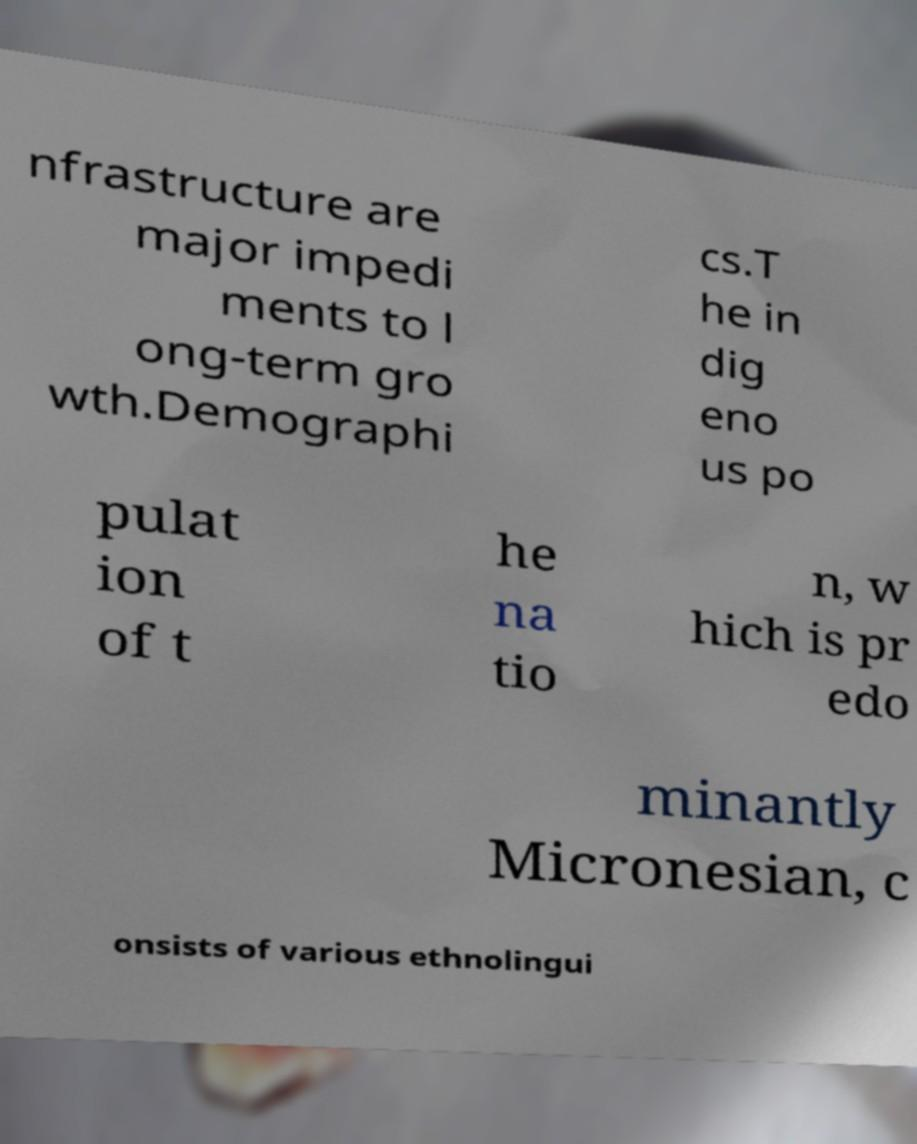Could you assist in decoding the text presented in this image and type it out clearly? nfrastructure are major impedi ments to l ong-term gro wth.Demographi cs.T he in dig eno us po pulat ion of t he na tio n, w hich is pr edo minantly Micronesian, c onsists of various ethnolingui 